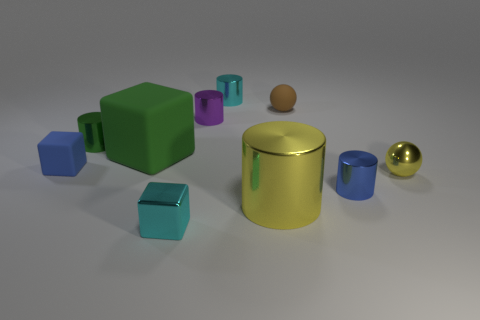Subtract all yellow cylinders. How many cylinders are left? 4 Subtract all cyan cylinders. How many cylinders are left? 4 Subtract all gray cylinders. Subtract all cyan balls. How many cylinders are left? 5 Subtract all cubes. How many objects are left? 7 Subtract all rubber spheres. Subtract all tiny balls. How many objects are left? 7 Add 5 purple things. How many purple things are left? 6 Add 5 yellow shiny things. How many yellow shiny things exist? 7 Subtract 0 red spheres. How many objects are left? 10 